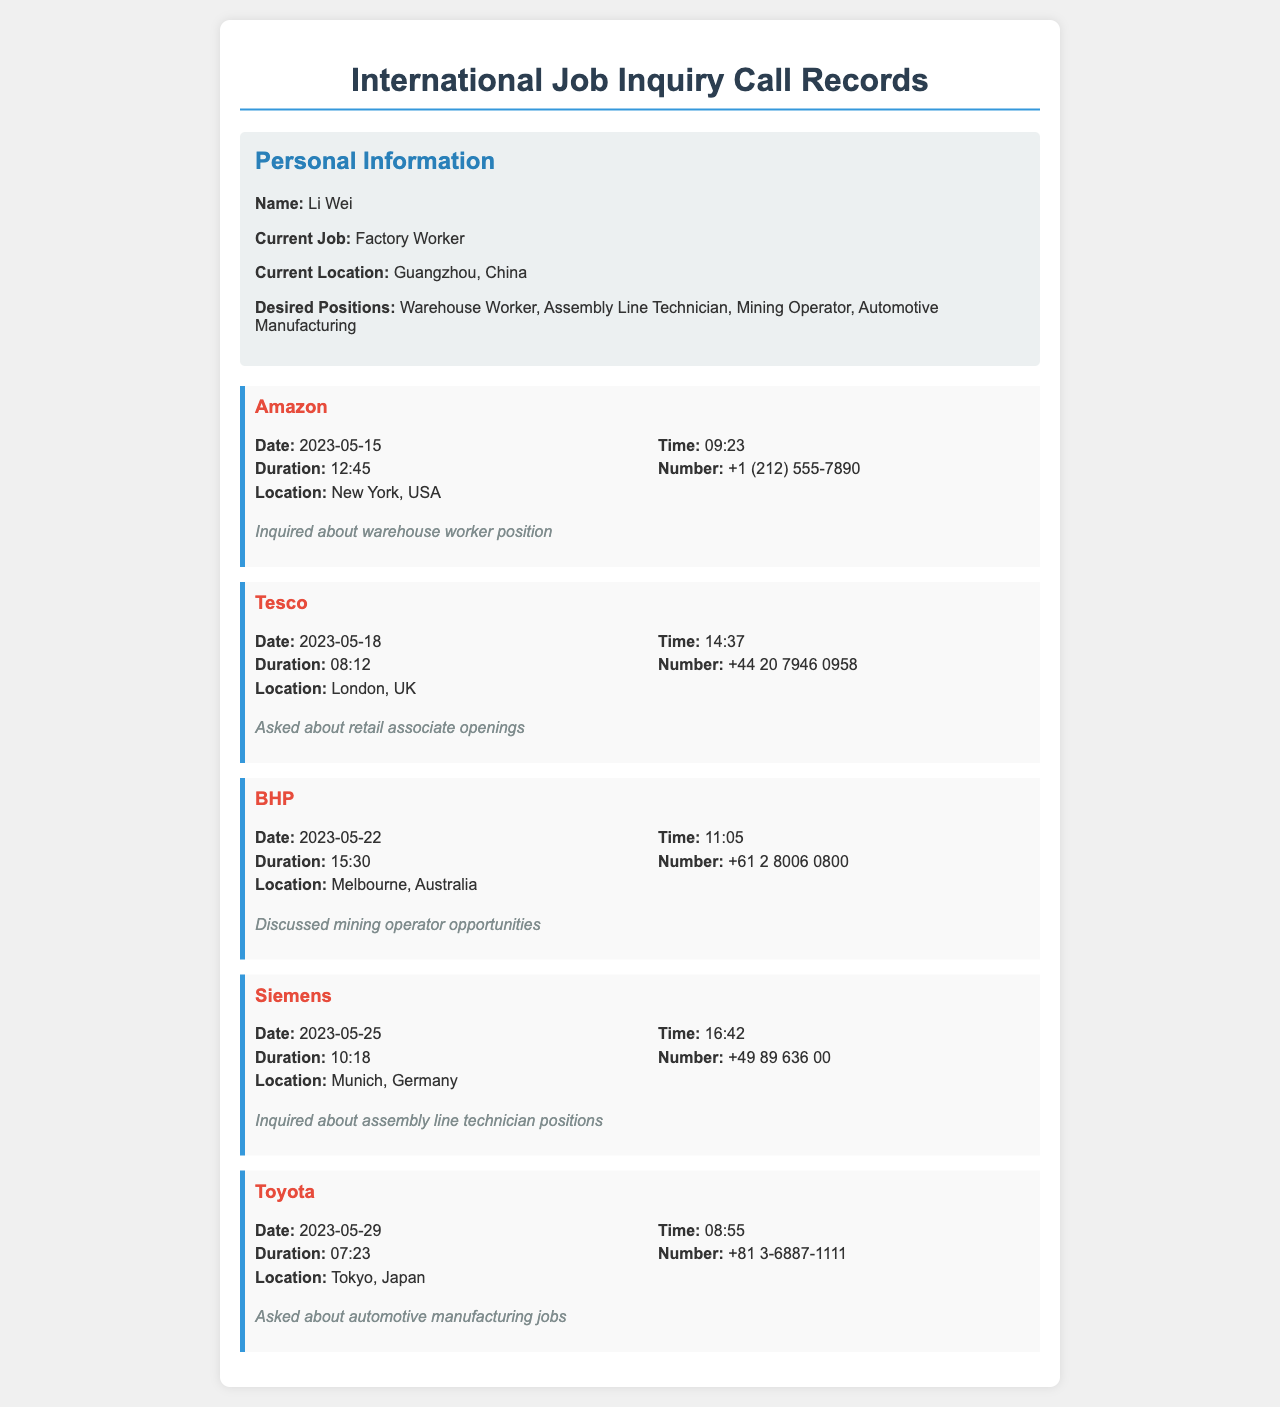What is the date of the call to Amazon? The date of the call can be found in the records under the Amazon entry, which is listed as 2023-05-15.
Answer: 2023-05-15 What job position was inquired about during the call to Tesco? The position inquired about can be found in the notes section of the Tesco entry, which states the inquiry was about retail associate openings.
Answer: retail associate openings How long was the call to BHP? The duration of the call to BHP is mentioned in the details, which shows it lasted for 15 minutes and 30 seconds.
Answer: 15:30 What is the location of the call to Siemens? The location for the Siemens call is recorded in the call details as Munich, Germany.
Answer: Munich, Germany Which company was called on May 29, 2023? The document contains the date and associated company call, which can be found under the entry indicating it was Toyota.
Answer: Toyota How many calls were made regarding automotive manufacturing jobs? The document includes only one entry for automotive manufacturing jobs, specifically the call to Toyota.
Answer: 1 What is the number for the call made to Tesco? The telephone number for Tesco is listed in the call details and can be found as +44 20 7946 0958.
Answer: +44 20 7946 0958 What position was discussed in the call to BHP? The position discussed during the call to BHP is noted in the documentation as mining operator opportunities.
Answer: mining operator opportunities 